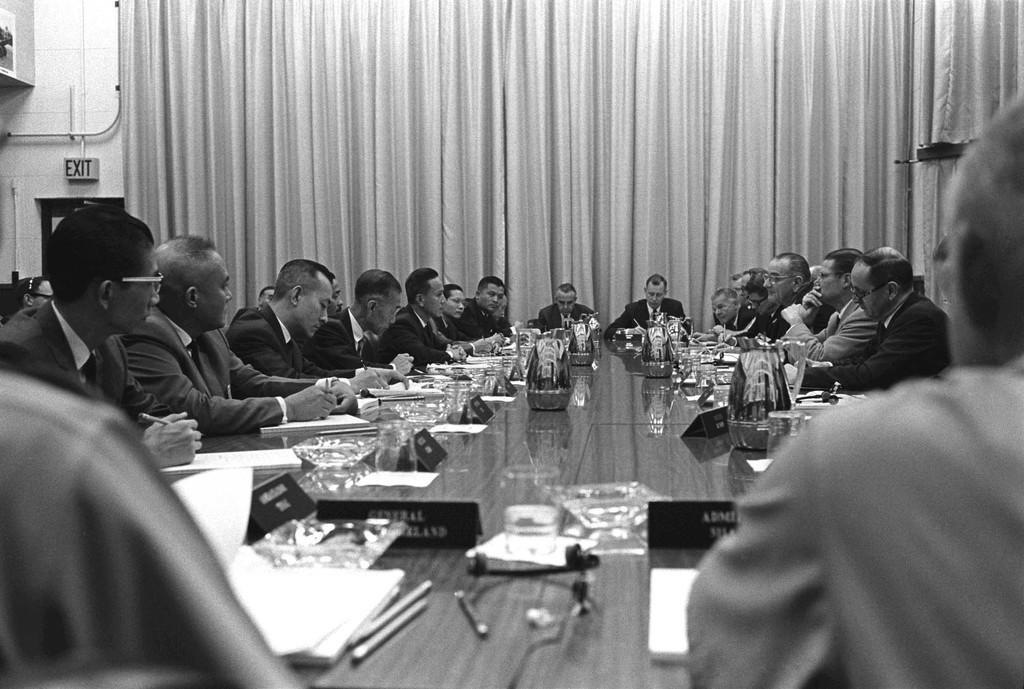Please provide a concise description of this image. In this image I can see number of people are sitting around this table. On this table I can see few pens and number of papers. In the background I can see curtains and a exit board. 